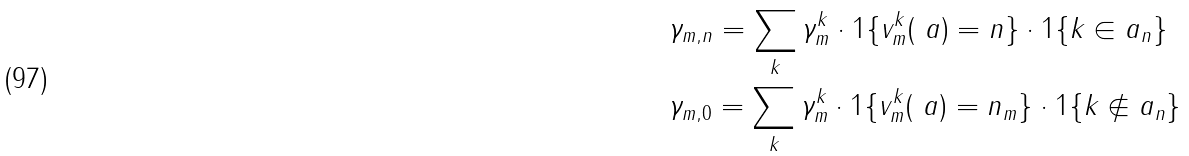Convert formula to latex. <formula><loc_0><loc_0><loc_500><loc_500>& \gamma _ { m , n } = \sum _ { k } \gamma ^ { k } _ { m } \cdot 1 \{ v ^ { k } _ { m } ( \ a ) = n \} \cdot 1 \{ k \in a _ { n } \} \\ & \gamma _ { m , 0 } = \sum _ { k } \gamma ^ { k } _ { m } \cdot 1 \{ v ^ { k } _ { m } ( \ a ) = n _ { m } \} \cdot 1 \{ k \not \in a _ { n } \}</formula> 